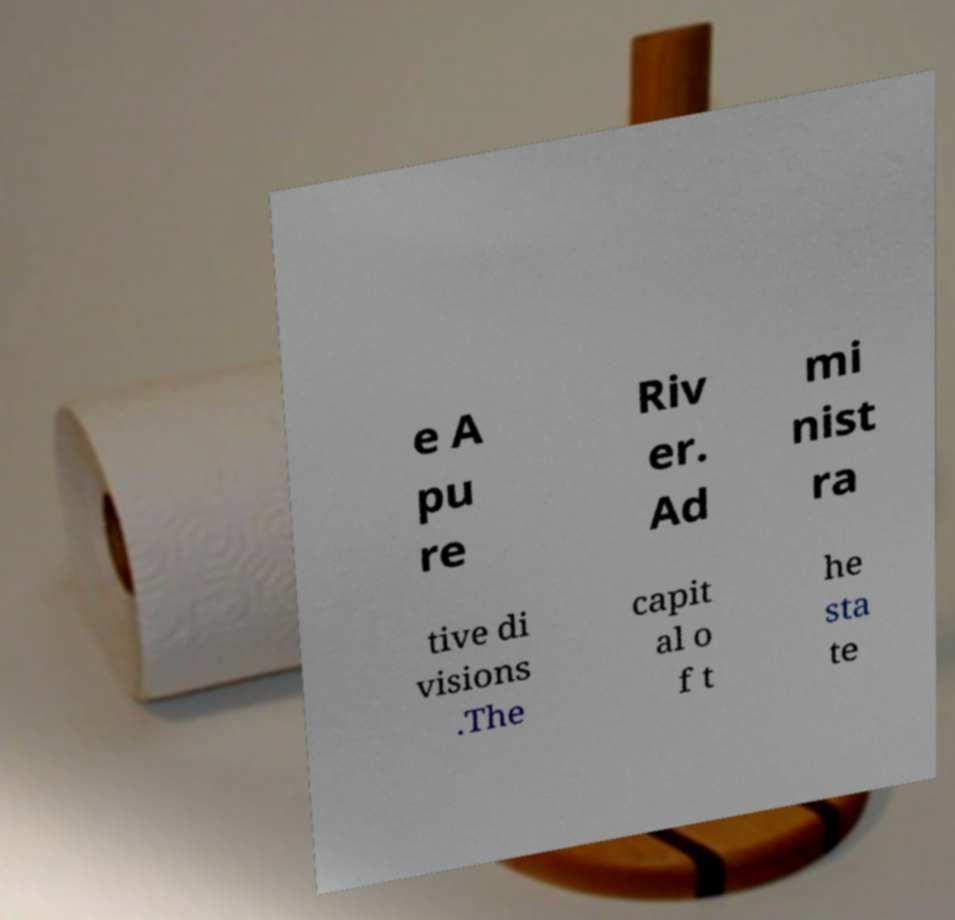Please identify and transcribe the text found in this image. e A pu re Riv er. Ad mi nist ra tive di visions .The capit al o f t he sta te 